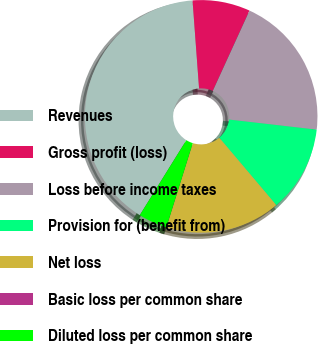Convert chart to OTSL. <chart><loc_0><loc_0><loc_500><loc_500><pie_chart><fcel>Revenues<fcel>Gross profit (loss)<fcel>Loss before income taxes<fcel>Provision for (benefit from)<fcel>Net loss<fcel>Basic loss per common share<fcel>Diluted loss per common share<nl><fcel>39.98%<fcel>8.0%<fcel>20.0%<fcel>12.0%<fcel>16.0%<fcel>0.01%<fcel>4.01%<nl></chart> 